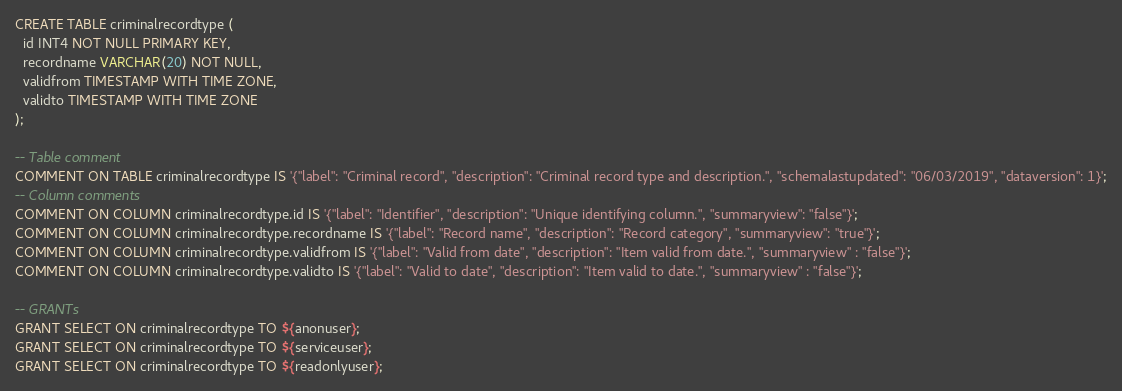Convert code to text. <code><loc_0><loc_0><loc_500><loc_500><_SQL_>CREATE TABLE criminalrecordtype (
  id INT4 NOT NULL PRIMARY KEY,
  recordname VARCHAR(20) NOT NULL,
  validfrom TIMESTAMP WITH TIME ZONE,
  validto TIMESTAMP WITH TIME ZONE
);

-- Table comment
COMMENT ON TABLE criminalrecordtype IS '{"label": "Criminal record", "description": "Criminal record type and description.", "schemalastupdated": "06/03/2019", "dataversion": 1}';
-- Column comments
COMMENT ON COLUMN criminalrecordtype.id IS '{"label": "Identifier", "description": "Unique identifying column.", "summaryview": "false"}';
COMMENT ON COLUMN criminalrecordtype.recordname IS '{"label": "Record name", "description": "Record category", "summaryview": "true"}';
COMMENT ON COLUMN criminalrecordtype.validfrom IS '{"label": "Valid from date", "description": "Item valid from date.", "summaryview" : "false"}';
COMMENT ON COLUMN criminalrecordtype.validto IS '{"label": "Valid to date", "description": "Item valid to date.", "summaryview" : "false"}';

-- GRANTs
GRANT SELECT ON criminalrecordtype TO ${anonuser};
GRANT SELECT ON criminalrecordtype TO ${serviceuser};
GRANT SELECT ON criminalrecordtype TO ${readonlyuser};
</code> 